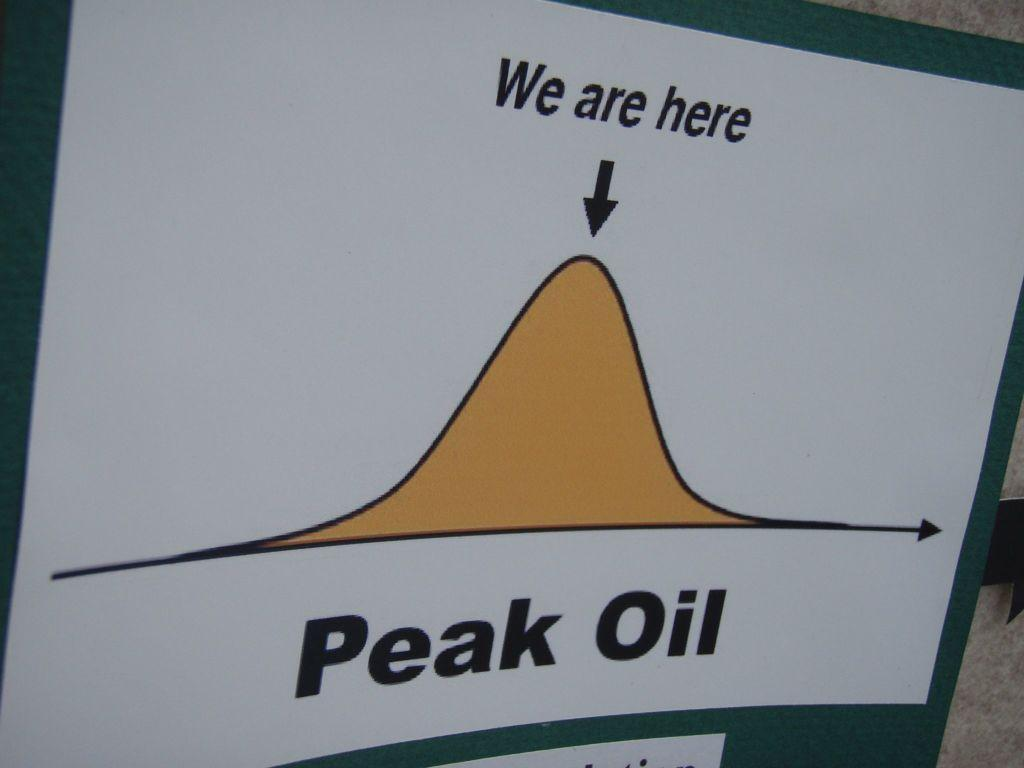<image>
Write a terse but informative summary of the picture. The bell curve diagram showed where the company was ranked. 